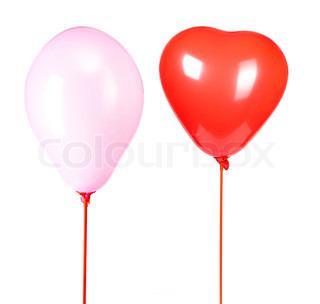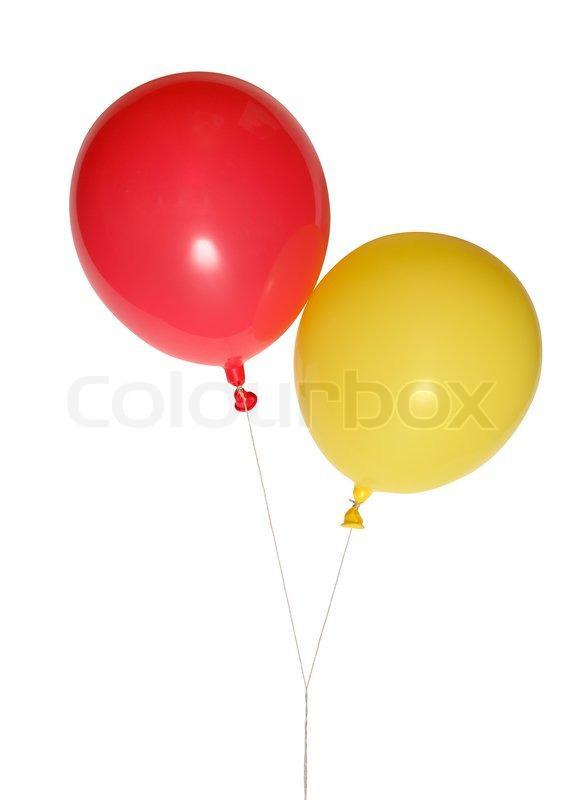The first image is the image on the left, the second image is the image on the right. Considering the images on both sides, is "There are two red balloons and two green balloons" valid? Answer yes or no. No. The first image is the image on the left, the second image is the image on the right. Analyze the images presented: Is the assertion "There is a heart shaped balloon" valid? Answer yes or no. Yes. 